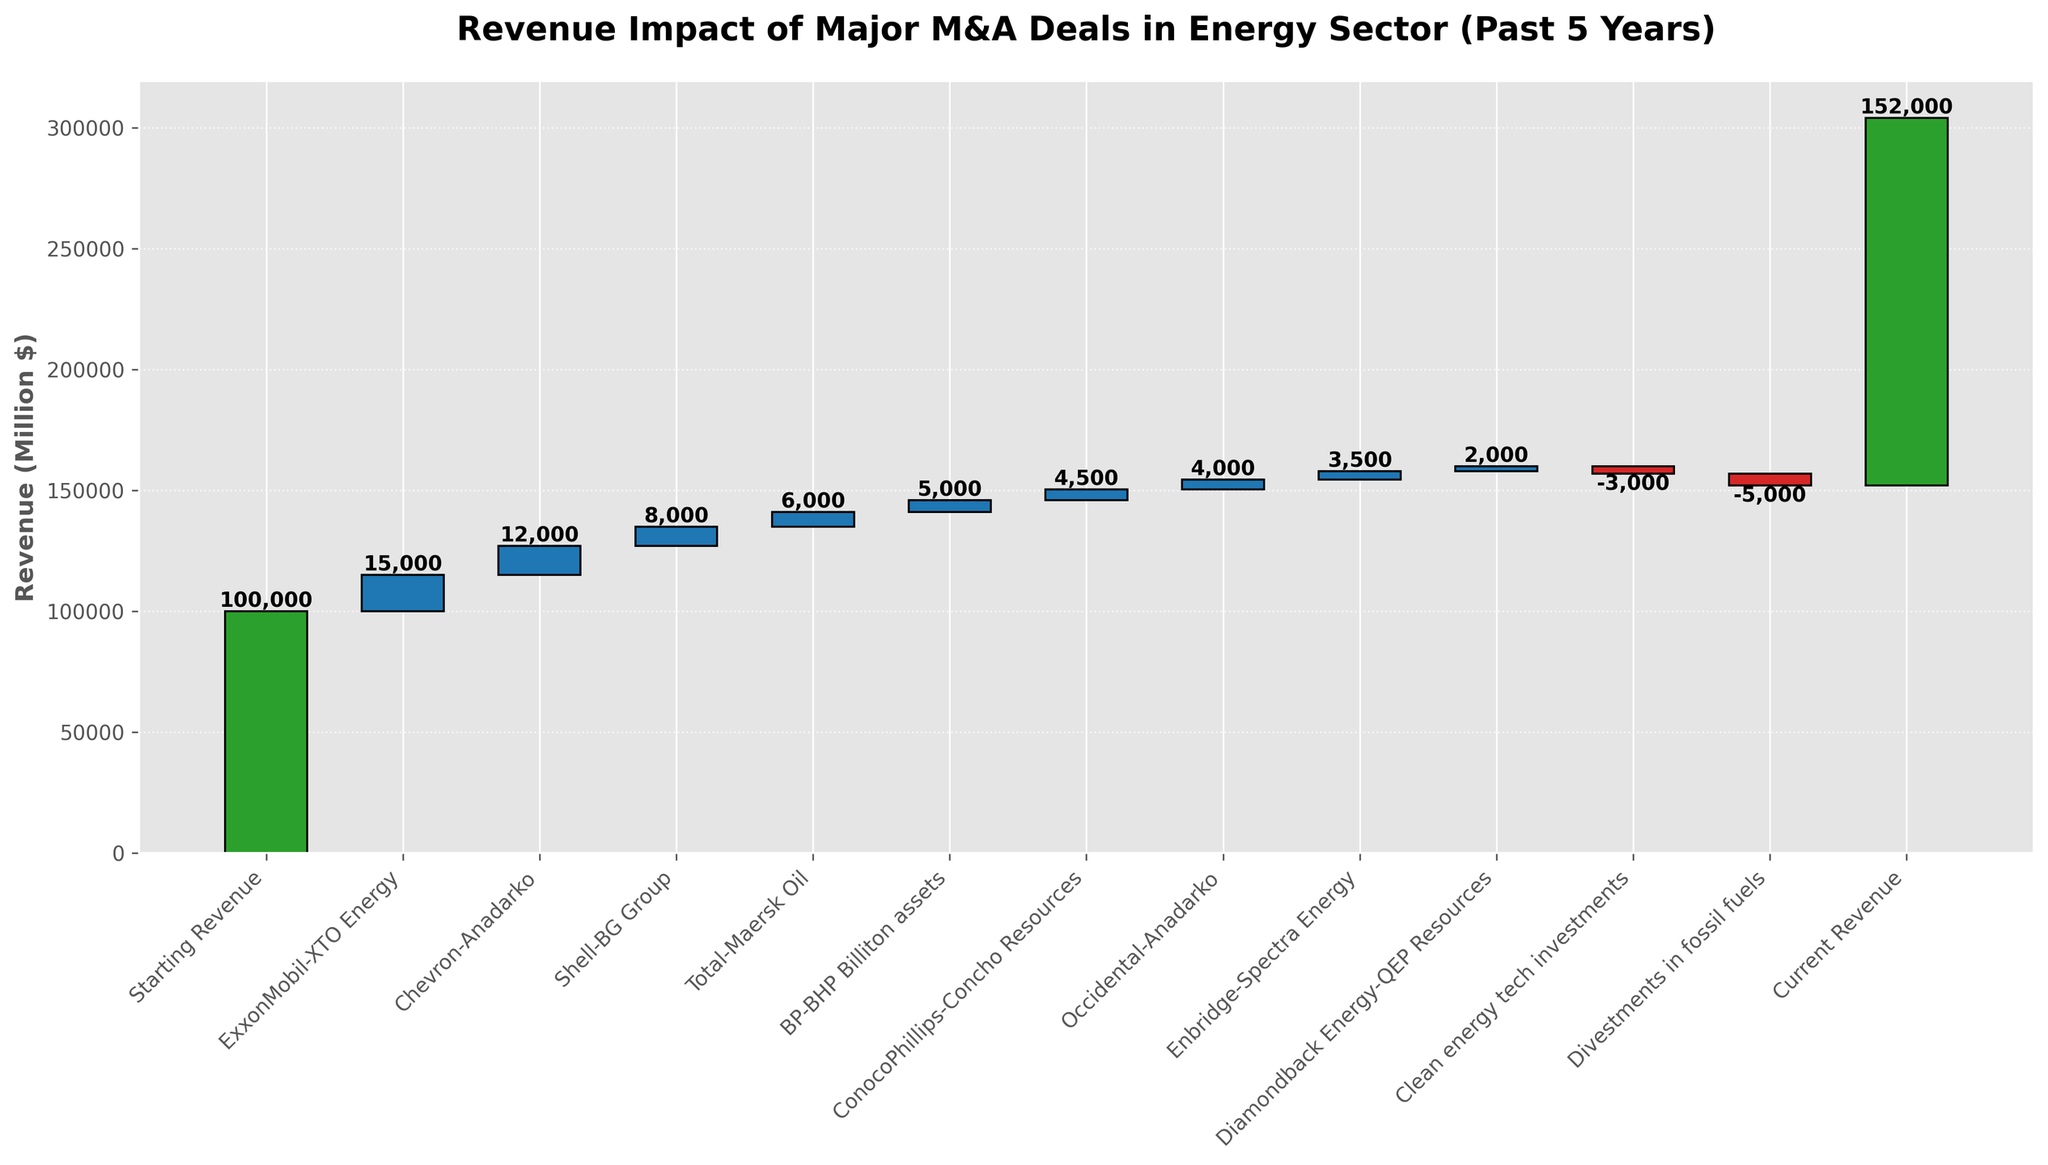What's the title of the figure? The title of the figure is shown at the top, and it reads "Revenue Impact of Major M&A Deals in Energy Sector (Past 5 Years)".
Answer: Revenue Impact of Major M&A Deals in Energy Sector (Past 5 Years) What is the starting revenue? The starting revenue is the first bar in the chart, which is labeled "Starting Revenue" and has a value at the top indicating its amount.
Answer: 100,000 How much revenue was impacted by the deal between ExxonMobil and XTO Energy? The bar labeled "ExxonMobil-XTO Energy" shows an increase in revenue, and the value at the top of the bar is noted.
Answer: 15,000 What is the cumulative revenue after the Chevron-Anadarko deal? Starting from 100,000, the ExxonMobil-XTO Energy deal adds 15,000 making it 115,000. Adding the Chevron-Anadarko deal's 12,000 to this gives the cumulative revenue.
Answer: 127,000 Which M&A deal had the smallest revenue impact? By comparing the heights of all positive bars, the smallest one is "Diamondback Energy-QEP Resources", and checking the value label confirms this.
Answer: 2,000 What impact did clean energy tech investments have on the revenue? The bar labeled "Clean energy tech investments" shows a decrease in revenue, with a value label indicating the amount.
Answer: -3,000 Calculate the total revenue added by all M&A deals before considering divestments and investments. Sum up the values from the M&A deals: 15,000 (ExxonMobil-XTO Energy) + 12,000 (Chevron-Anadarko) + 8,000 (Shell-BG Group) + 6,000 (Total-Maersk Oil) + 5,000 (BP-BHP Billiton assets) + 4,500 (ConocoPhillips-Concho Resources) + 4,000 (Occidental-Anadarko) + 3,500 (Enbridge-Spectra Energy) + 2,000 (Diamondback Energy-QEP Resources). The total is 60,000.
Answer: 60,000 Compare the revenue impact of divestments in fossil fuels to clean energy tech investments. Which has a greater impact? Both bars show decreases in revenue, but "Divestments in fossil fuels" is taller and has a larger negative value compared to "Clean energy tech investments".
Answer: Divestments in fossil fuels How much has the current revenue increased compared to the starting revenue? Subtract the starting revenue from the current revenue: 152,000 - 100,000 = 52,000.
Answer: 52,000 Which M&A deal involved Shell, and what was its impact on revenue? The bar labeled "Shell-BG Group" shows the impact, indicated by the value at its top.
Answer: Shell-BG Group, 8,000 